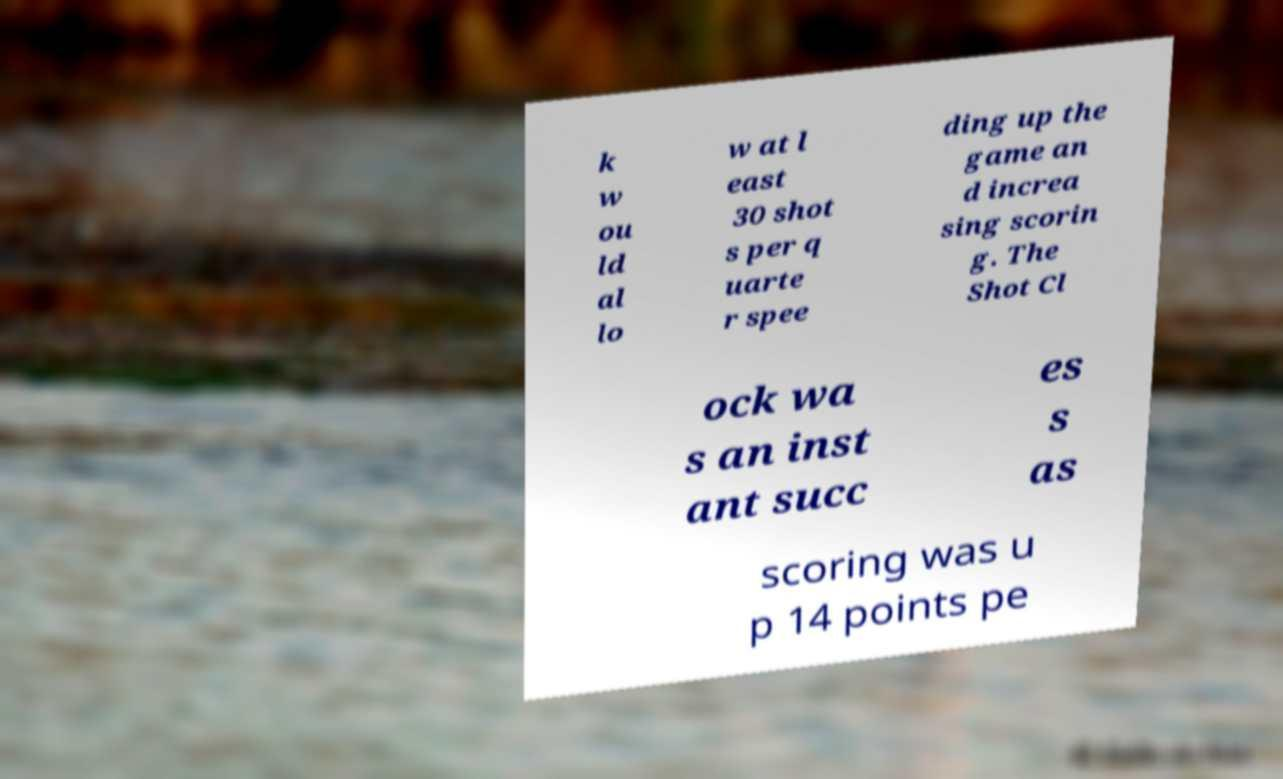Please identify and transcribe the text found in this image. k w ou ld al lo w at l east 30 shot s per q uarte r spee ding up the game an d increa sing scorin g. The Shot Cl ock wa s an inst ant succ es s as scoring was u p 14 points pe 